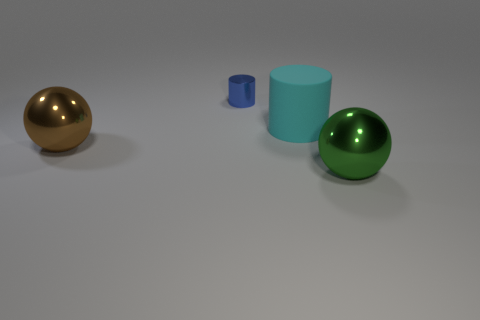What number of small blue metal things are the same shape as the cyan thing?
Keep it short and to the point. 1. Is there a big cylinder made of the same material as the cyan object?
Provide a short and direct response. No. What number of metal cylinders are there?
Make the answer very short. 1. What number of spheres are green things or blue things?
Your answer should be very brief. 1. What is the color of the cylinder that is the same size as the green sphere?
Offer a terse response. Cyan. How many things are both behind the cyan matte cylinder and in front of the tiny blue cylinder?
Keep it short and to the point. 0. What is the large cylinder made of?
Offer a very short reply. Rubber. What number of objects are brown metal blocks or matte things?
Your response must be concise. 1. Does the metallic thing left of the small blue cylinder have the same size as the cylinder on the right side of the blue cylinder?
Keep it short and to the point. Yes. How many other things are there of the same size as the rubber object?
Your answer should be very brief. 2. 